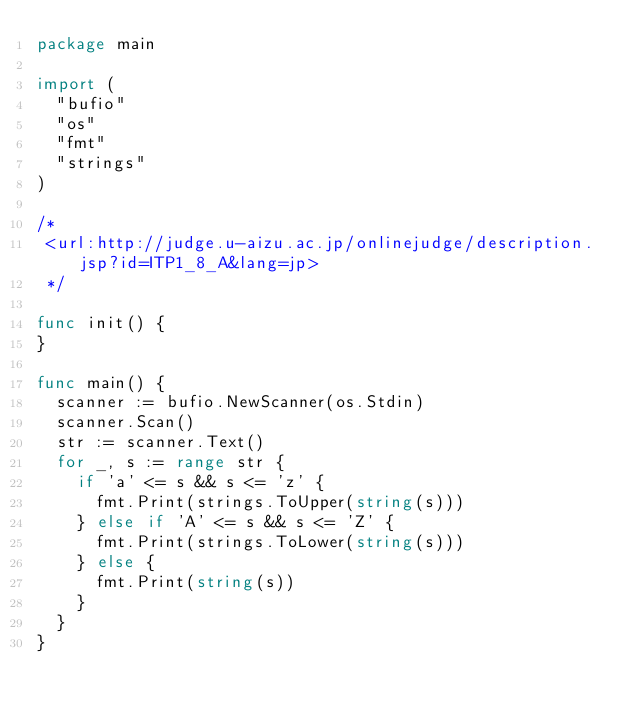<code> <loc_0><loc_0><loc_500><loc_500><_Go_>package main

import (
	"bufio"
	"os"
	"fmt"
	"strings"
)

/*
 <url:http://judge.u-aizu.ac.jp/onlinejudge/description.jsp?id=ITP1_8_A&lang=jp>
 */

func init() {
}

func main() {
	scanner := bufio.NewScanner(os.Stdin)
	scanner.Scan()
	str := scanner.Text()
	for _, s := range str {
		if 'a' <= s && s <= 'z' {
			fmt.Print(strings.ToUpper(string(s)))
		} else if 'A' <= s && s <= 'Z' {
			fmt.Print(strings.ToLower(string(s)))
		} else {
			fmt.Print(string(s))
		}
	}
}</code> 